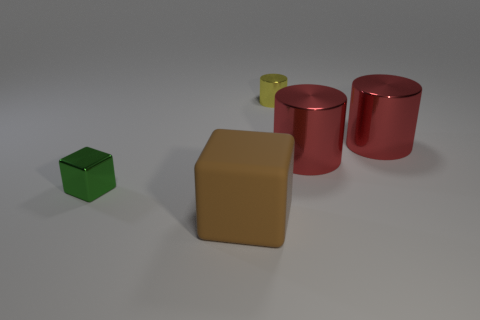Add 2 red cylinders. How many objects exist? 7 Subtract all cubes. How many objects are left? 3 Subtract all big gray metal blocks. Subtract all small yellow cylinders. How many objects are left? 4 Add 3 small metal cubes. How many small metal cubes are left? 4 Add 3 large shiny objects. How many large shiny objects exist? 5 Subtract 0 blue cylinders. How many objects are left? 5 